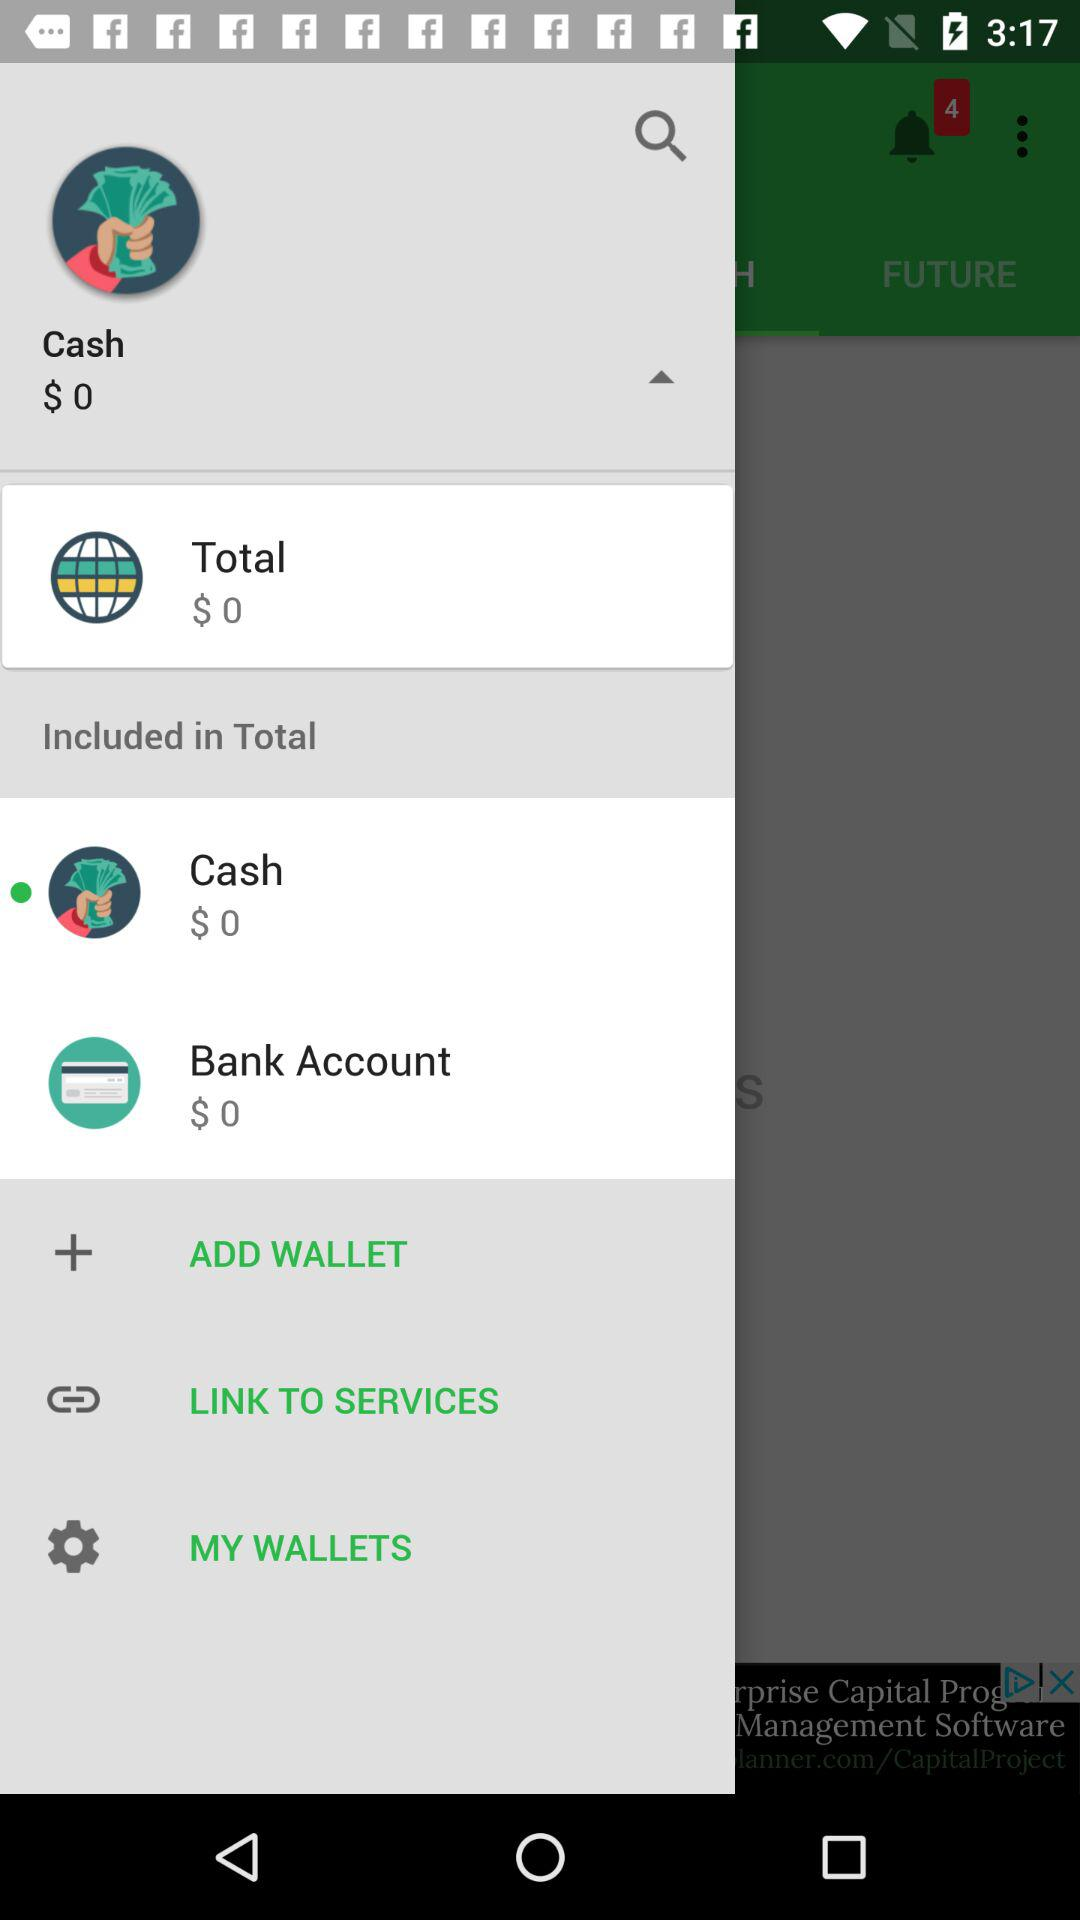How much cash balance is there? The cash balance is $0. 